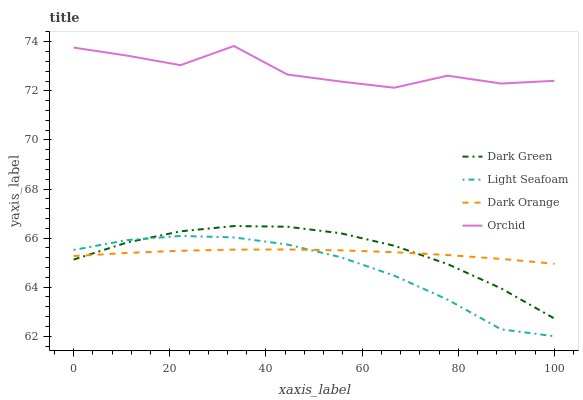Does Light Seafoam have the minimum area under the curve?
Answer yes or no. Yes. Does Orchid have the maximum area under the curve?
Answer yes or no. Yes. Does Dark Orange have the minimum area under the curve?
Answer yes or no. No. Does Dark Orange have the maximum area under the curve?
Answer yes or no. No. Is Dark Orange the smoothest?
Answer yes or no. Yes. Is Orchid the roughest?
Answer yes or no. Yes. Is Light Seafoam the smoothest?
Answer yes or no. No. Is Light Seafoam the roughest?
Answer yes or no. No. Does Light Seafoam have the lowest value?
Answer yes or no. Yes. Does Dark Orange have the lowest value?
Answer yes or no. No. Does Orchid have the highest value?
Answer yes or no. Yes. Does Light Seafoam have the highest value?
Answer yes or no. No. Is Light Seafoam less than Orchid?
Answer yes or no. Yes. Is Orchid greater than Light Seafoam?
Answer yes or no. Yes. Does Dark Green intersect Light Seafoam?
Answer yes or no. Yes. Is Dark Green less than Light Seafoam?
Answer yes or no. No. Is Dark Green greater than Light Seafoam?
Answer yes or no. No. Does Light Seafoam intersect Orchid?
Answer yes or no. No. 